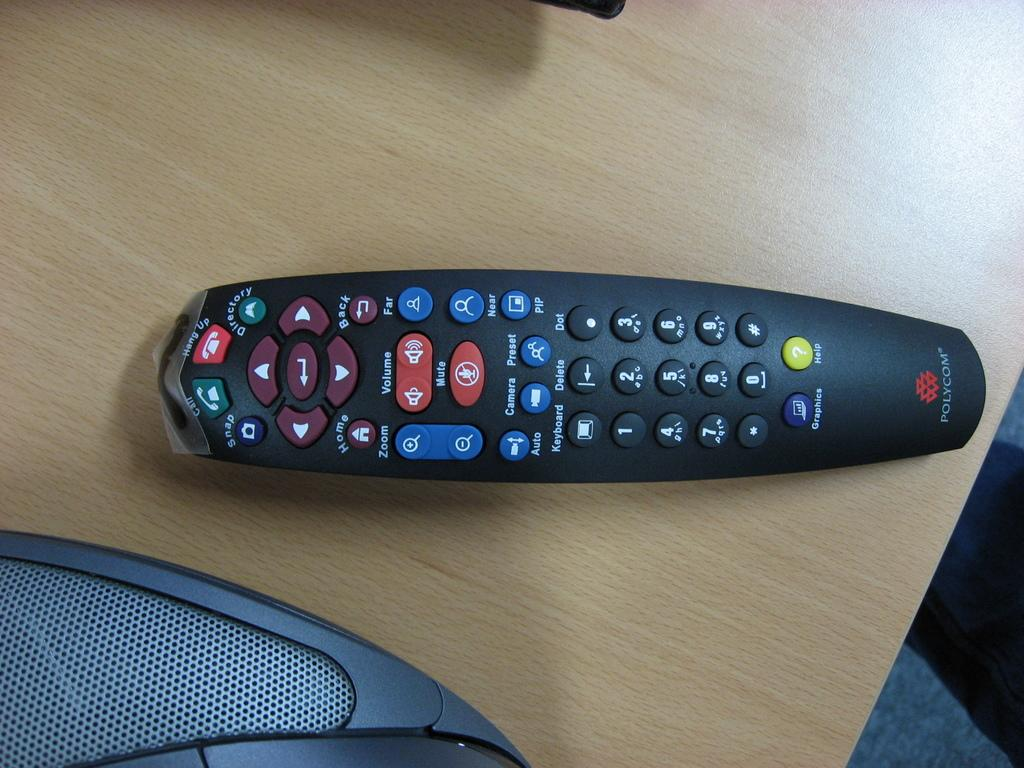<image>
Give a short and clear explanation of the subsequent image. The TV remote on the table was made by a company Polycom. 